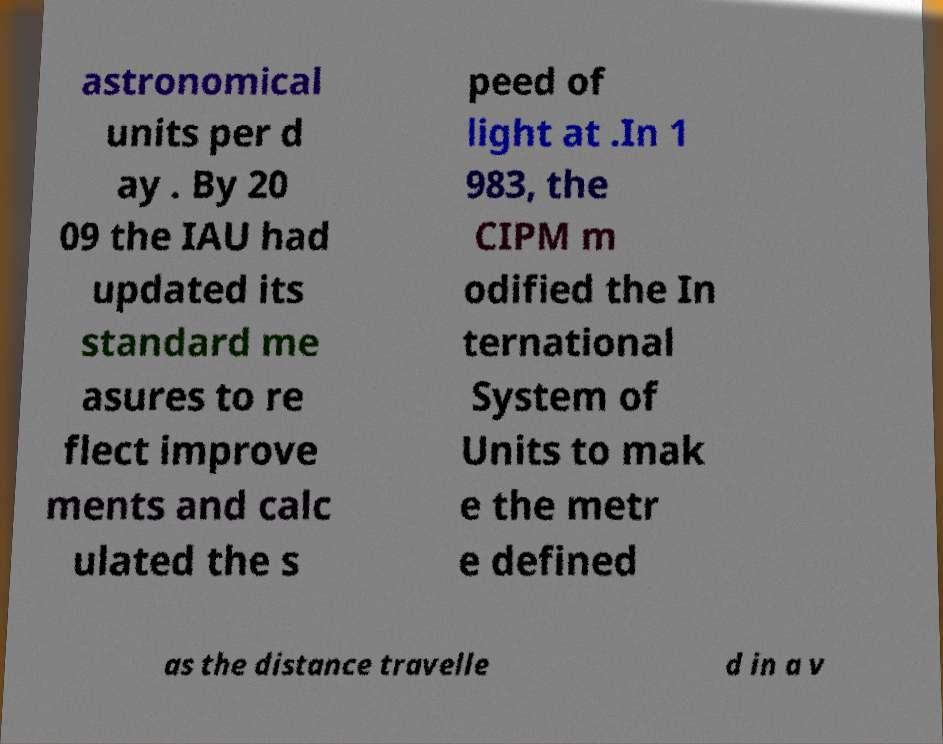Please read and relay the text visible in this image. What does it say? astronomical units per d ay . By 20 09 the IAU had updated its standard me asures to re flect improve ments and calc ulated the s peed of light at .In 1 983, the CIPM m odified the In ternational System of Units to mak e the metr e defined as the distance travelle d in a v 